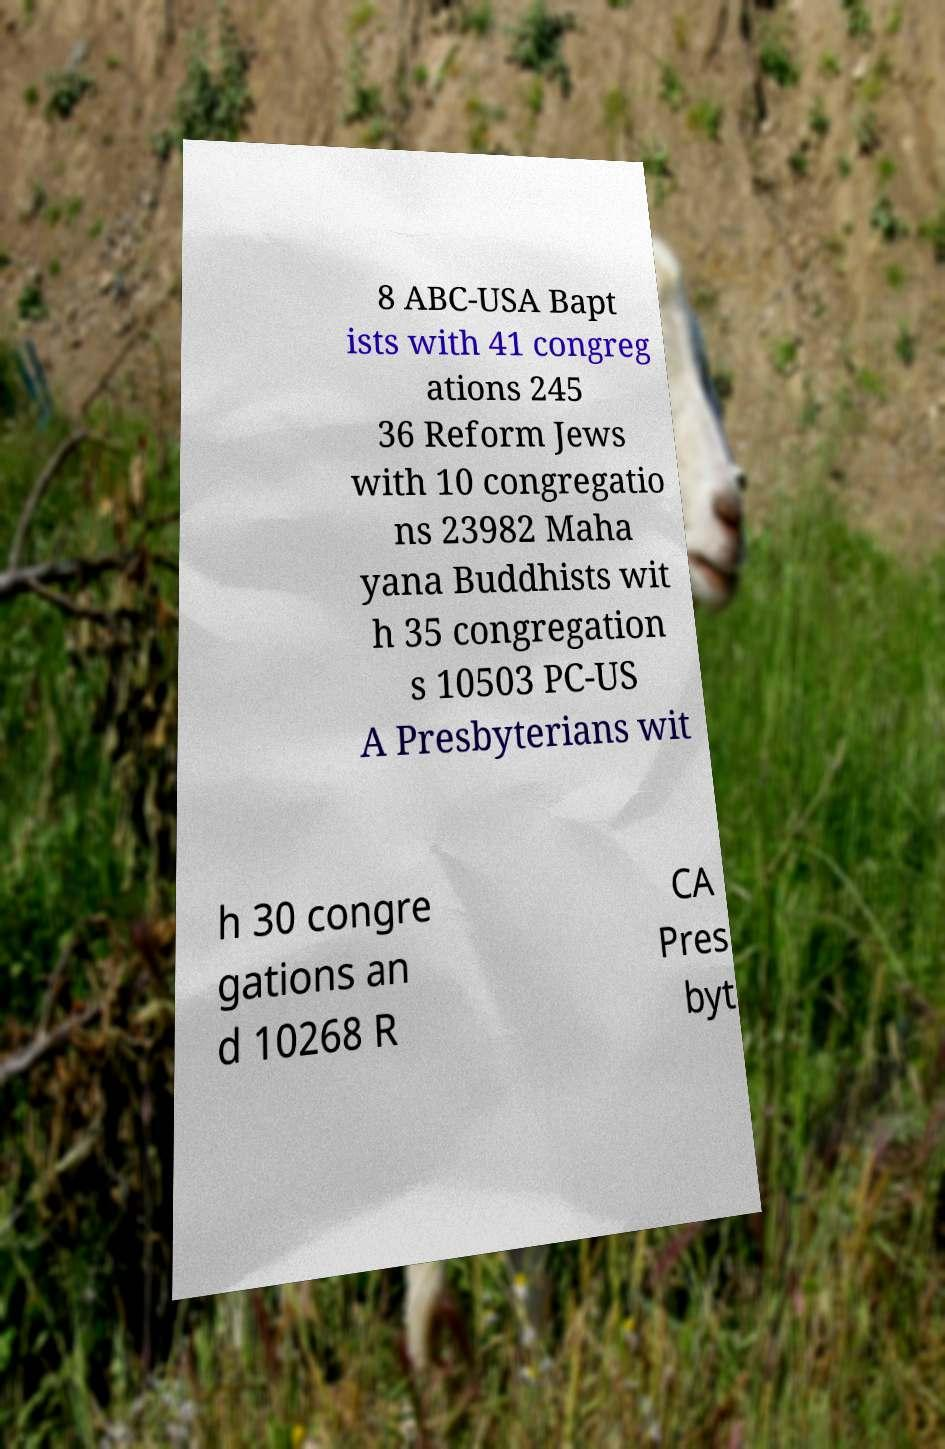There's text embedded in this image that I need extracted. Can you transcribe it verbatim? 8 ABC-USA Bapt ists with 41 congreg ations 245 36 Reform Jews with 10 congregatio ns 23982 Maha yana Buddhists wit h 35 congregation s 10503 PC-US A Presbyterians wit h 30 congre gations an d 10268 R CA Pres byt 